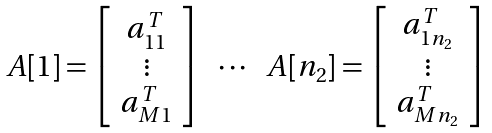<formula> <loc_0><loc_0><loc_500><loc_500>\begin{array} { c c c c } A [ 1 ] = \left [ \begin{array} { c } a _ { 1 1 } ^ { T } \\ \vdots \\ a _ { M 1 } ^ { T } \\ \end{array} \right ] & \cdots & A [ n _ { 2 } ] = \left [ \begin{array} { c } a _ { 1 n _ { 2 } } ^ { T } \\ \vdots \\ a _ { M n _ { 2 } } ^ { T } \\ \end{array} \right ] \end{array}</formula> 